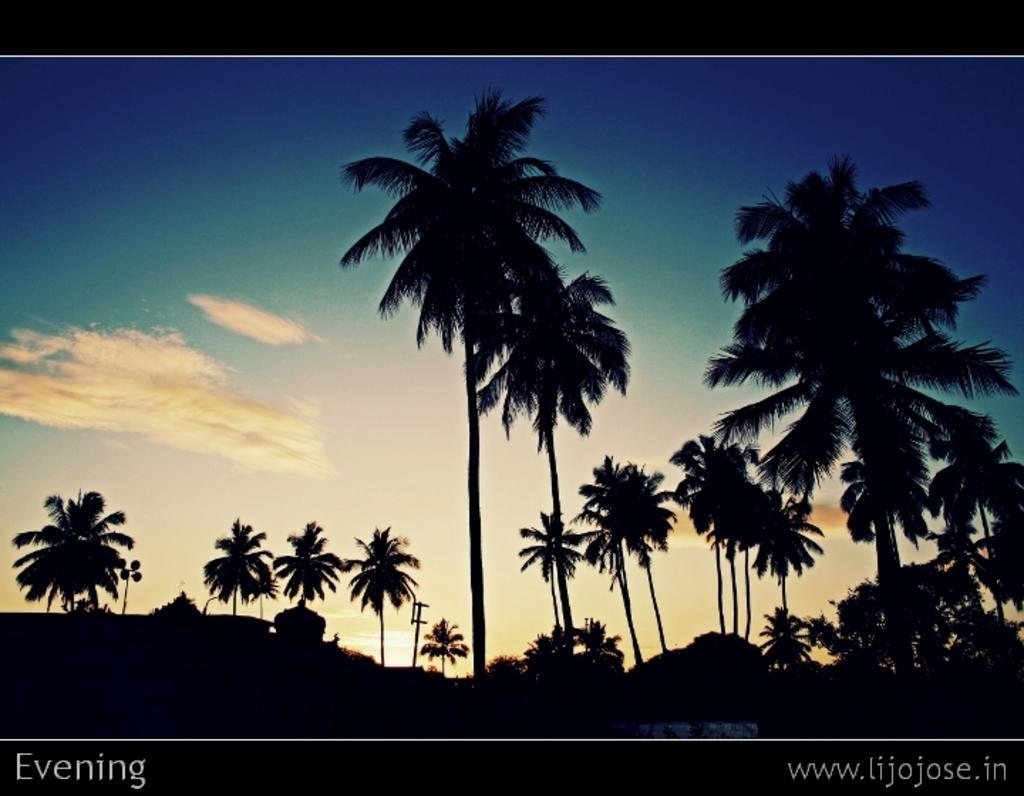Please provide a concise description of this image. In this image I see a number of trees and the sky. 